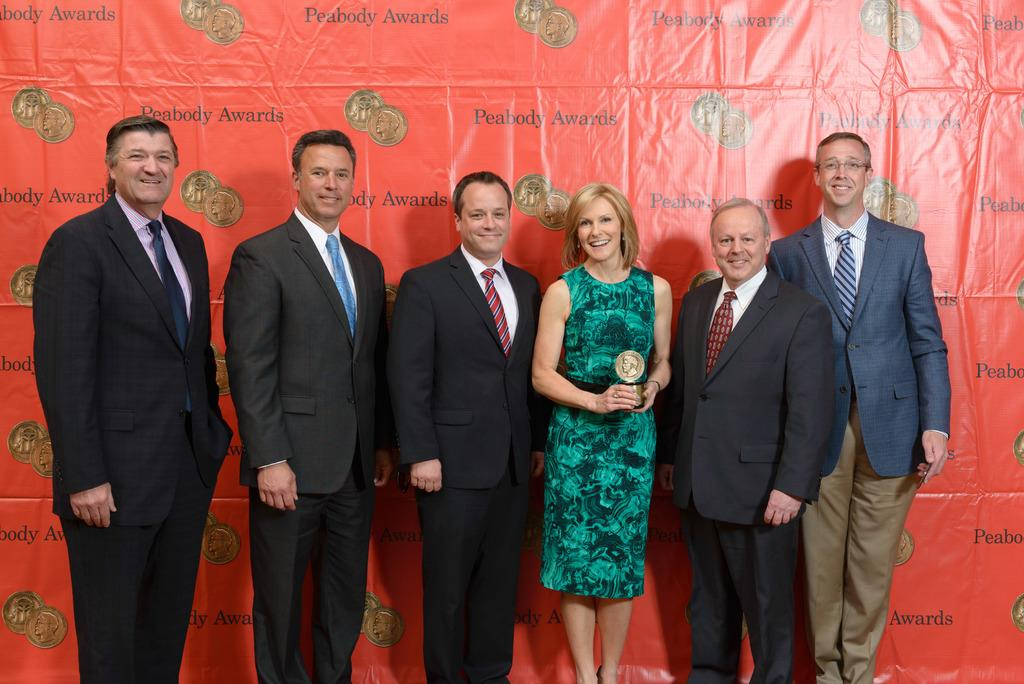What is the prominent color of the banner in the image? The banner in the image is red. What is depicted on the banner? The banner has images of coins and text on it. How many men are in the image? There are five men in the image. How many women are in the image? There is one woman in the image. What is the woman holding in the image? The woman is holding a trophy. What is the general mood of the people in the image? All the people in the image are smiling, which suggests a positive mood. What type of haircut is the woman giving to the man in the image? There is no man getting a haircut in the image; the woman is holding a trophy. What type of writing instrument is the man using to write on the banner in the image? There is no man writing on the banner in the image; the banner has text and images of coins on it. 